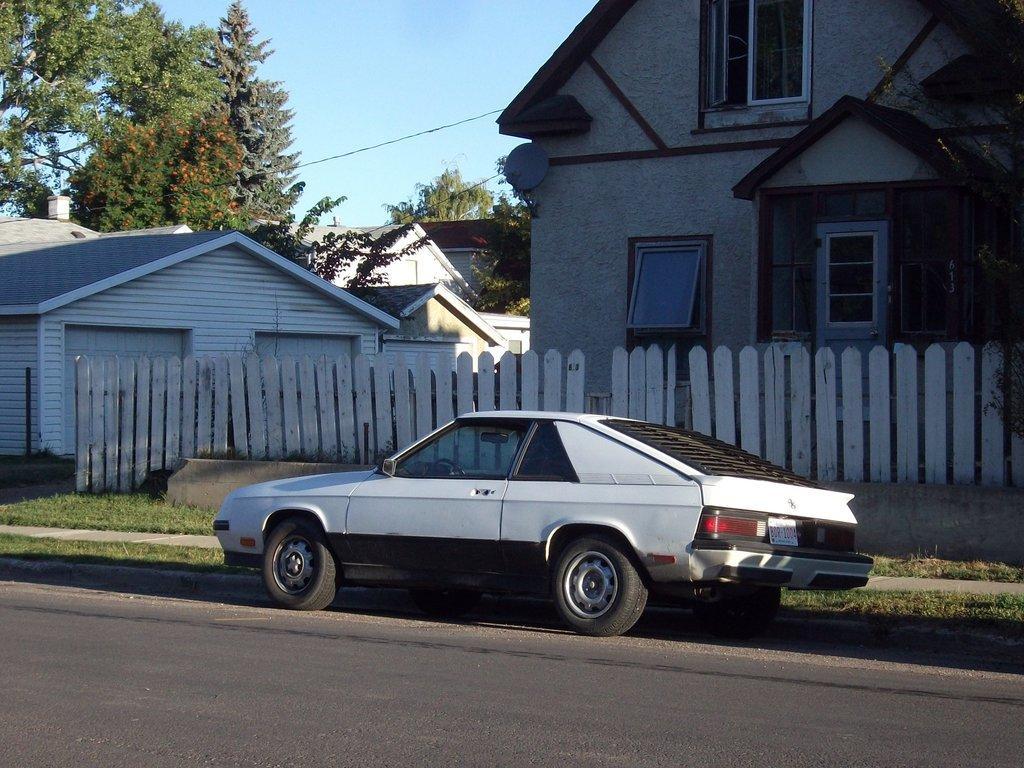Can you describe this image briefly? In this Image I can see a vehicle,fencing,few buildings,glass windows,wire and trees. The sky is in blue color. 